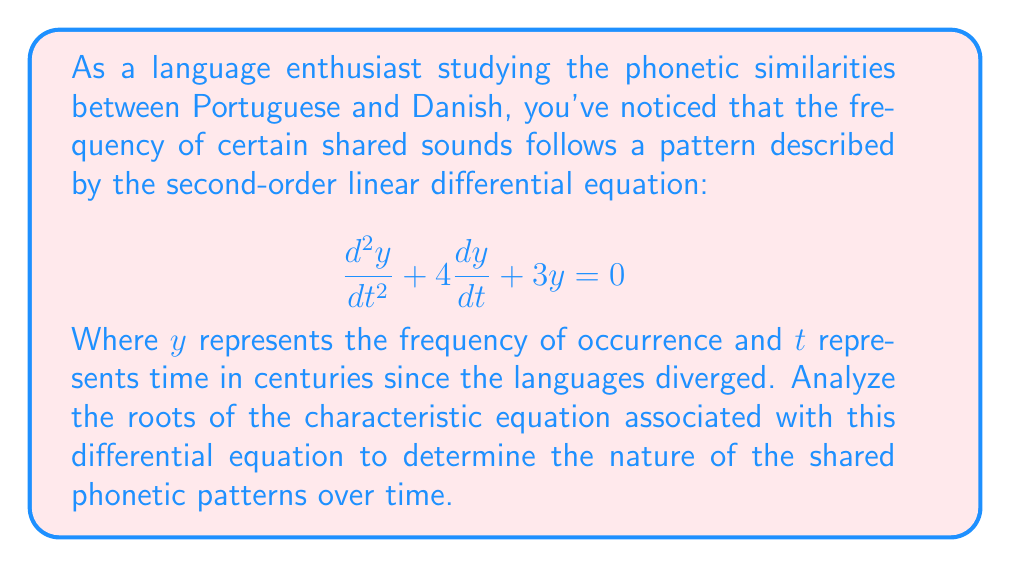What is the answer to this math problem? To analyze the roots of the characteristic equation, we follow these steps:

1) The general form of a second-order linear differential equation is:
   $$\frac{d^2y}{dt^2} + a\frac{dy}{dt} + by = 0$$

2) In this case, $a = 4$ and $b = 3$.

3) The characteristic equation is formed by replacing $\frac{d^2y}{dt^2}$ with $r^2$, $\frac{dy}{dt}$ with $r$, and $y$ with 1:
   $$r^2 + 4r + 3 = 0$$

4) This is a quadratic equation. We can solve it using the quadratic formula:
   $$r = \frac{-b \pm \sqrt{b^2 - 4ac}}{2a}$$
   Where $a = 1$, $b = 4$, and $c = 3$

5) Substituting these values:
   $$r = \frac{-4 \pm \sqrt{4^2 - 4(1)(3)}}{2(1)}$$
   $$r = \frac{-4 \pm \sqrt{16 - 12}}{2}$$
   $$r = \frac{-4 \pm \sqrt{4}}{2}$$
   $$r = \frac{-4 \pm 2}{2}$$

6) This gives us two roots:
   $$r_1 = \frac{-4 + 2}{2} = -1$$
   $$r_2 = \frac{-4 - 2}{2} = -3$$

7) Since both roots are real and distinct, the general solution to the differential equation is:
   $$y = c_1e^{-t} + c_2e^{-3t}$$
   Where $c_1$ and $c_2$ are constants determined by initial conditions.

8) The negative roots indicate that the shared phonetic patterns decrease exponentially over time, with one component decreasing more rapidly than the other.
Answer: $r_1 = -1$, $r_2 = -3$ 